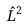Convert formula to latex. <formula><loc_0><loc_0><loc_500><loc_500>\hat { L } ^ { 2 }</formula> 